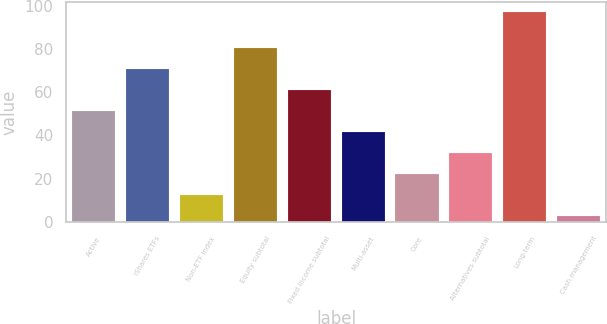Convert chart to OTSL. <chart><loc_0><loc_0><loc_500><loc_500><bar_chart><fcel>Active<fcel>iShares ETFs<fcel>Non-ETF index<fcel>Equity subtotal<fcel>Fixed income subtotal<fcel>Multi-asset<fcel>Core<fcel>Alternatives subtotal<fcel>Long-term<fcel>Cash management<nl><fcel>51.5<fcel>70.9<fcel>12.7<fcel>80.6<fcel>61.2<fcel>41.8<fcel>22.4<fcel>32.1<fcel>97<fcel>3<nl></chart> 